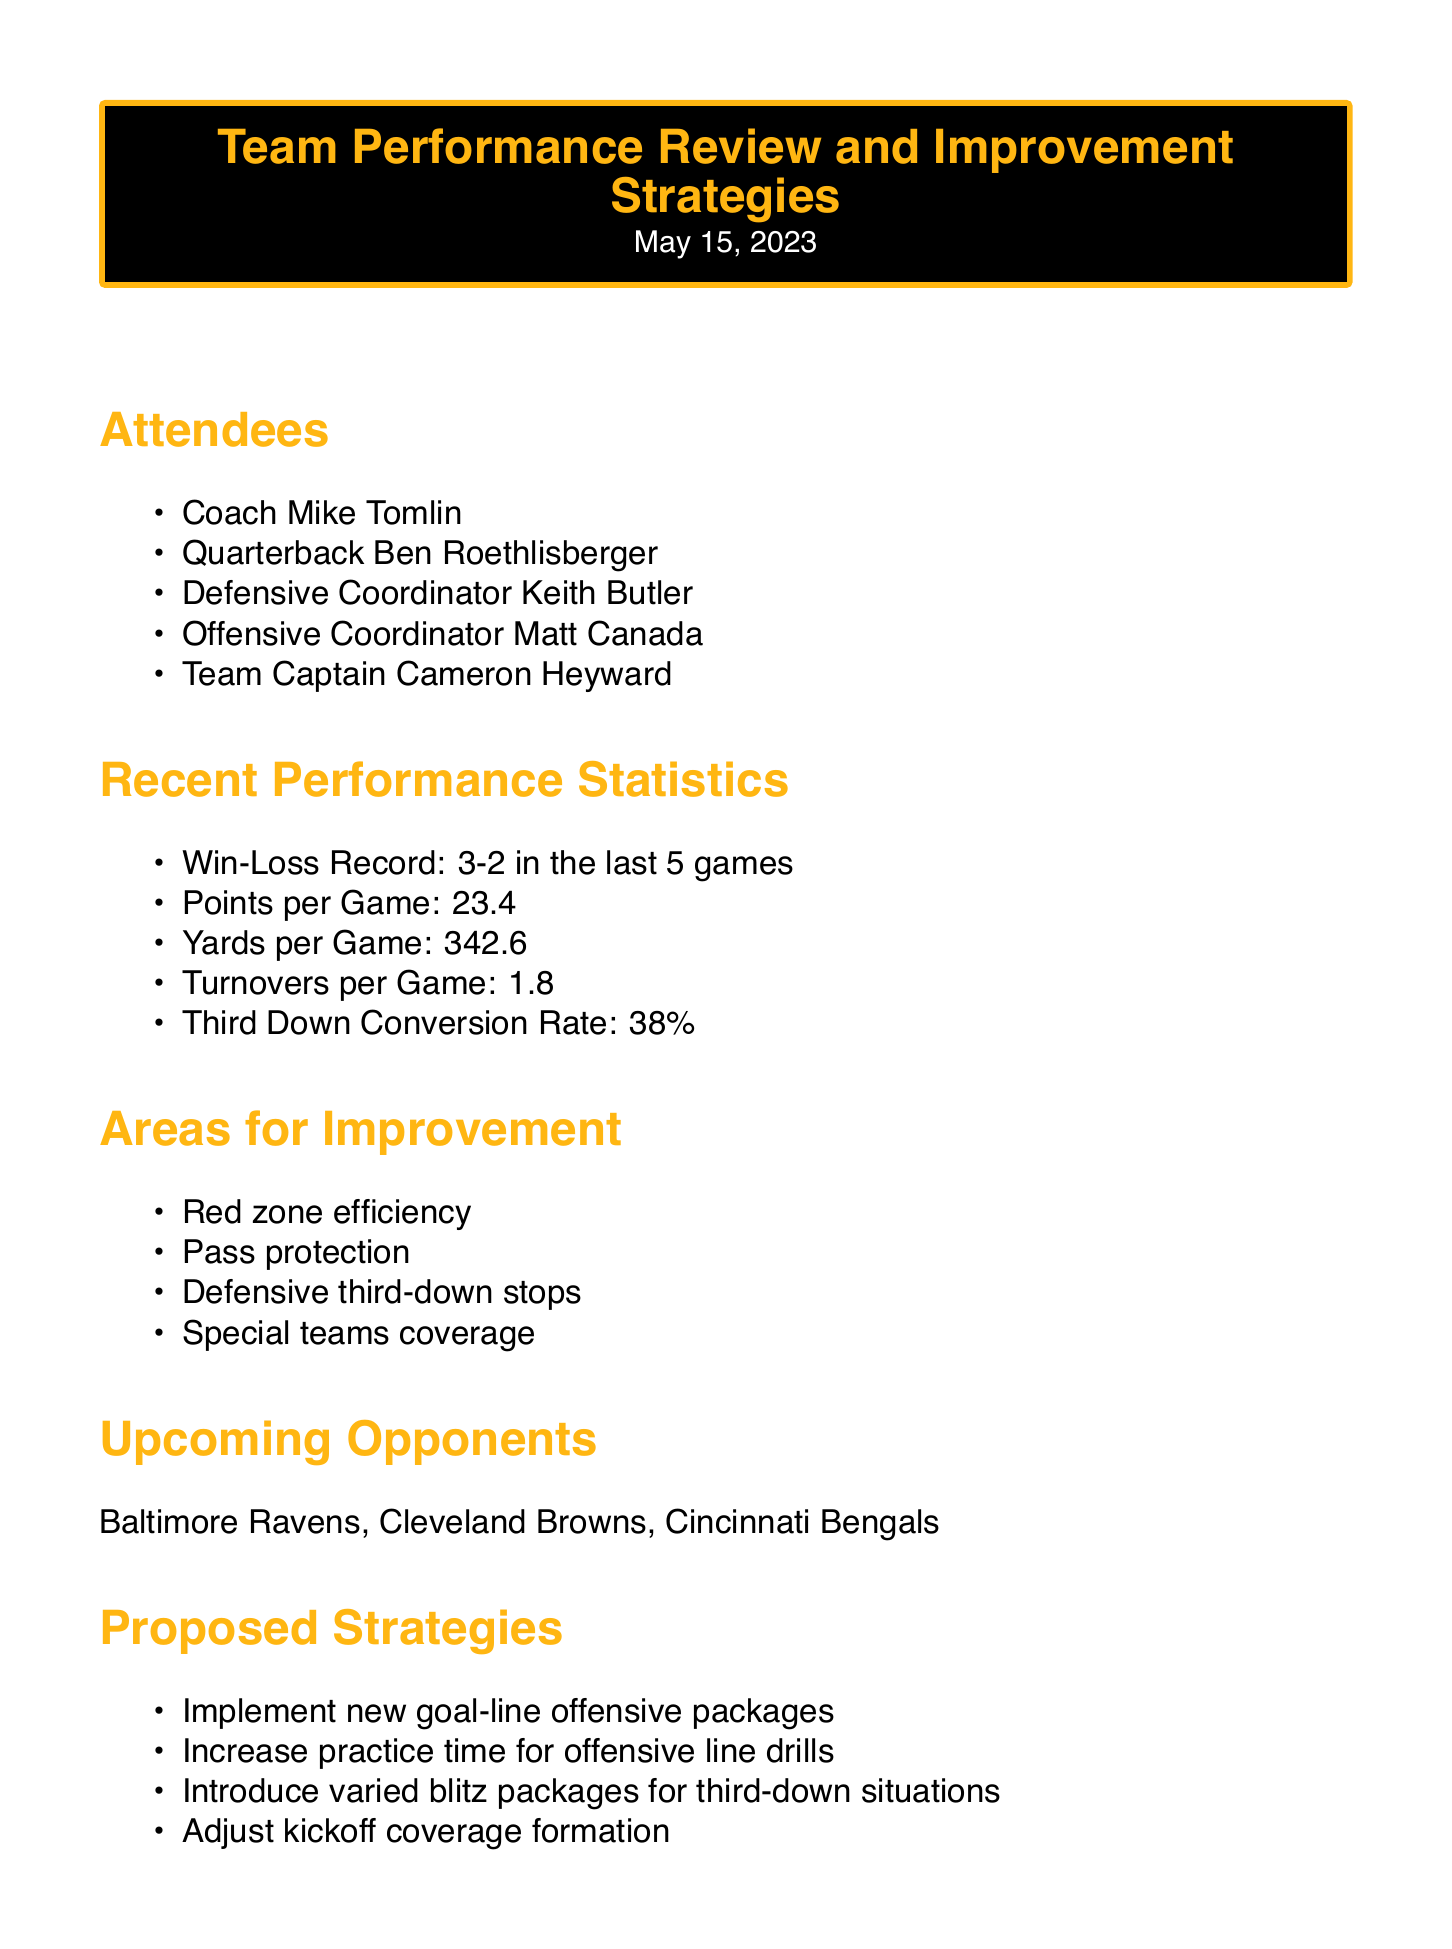What is the team's win-loss record in the last 5 games? The win-loss record is a performance statistic stated in the document, showing the results of the team's recent games.
Answer: 3-2 What is the average points scored per game? The average points per game is mentioned under recent performance statistics, providing insight into the team's offense.
Answer: 23.4 Which area needs improvement related to scoring opportunities? This area for improvement is identified in the document, highlighting a specific aspect of offensive performance.
Answer: Red zone efficiency What upcoming opponent is mentioned first? The order of the opponents listed indicates the sequence of upcoming challenges for the team.
Answer: Baltimore Ravens What strategy is proposed to address offensive challenges? This proposed strategy is aimed at enhancing the team's scoring ability, drawing on insights from the document.
Answer: Implement new goal-line offensive packages How many action items are listed for further improvement? The number of action items gives a clear indication of the planned steps to address performance issues outlined in the meeting.
Answer: 4 What is the third down conversion rate? This statistic provides insight into the effectiveness of the team's offensive plays in critical moments.
Answer: 38% What is the personal note regarding offensive inspiration? This note indicates the player's approach to innovating play designs through personal influences.
Answer: Draw from mom's artistic creativity to develop new play designs What team building idea is proposed? The idea suggests a way to enhance team cohesion through cultural engagement, as mentioned in the personal notes.
Answer: Organize team visit to local art museum for fresh perspective and bonding 